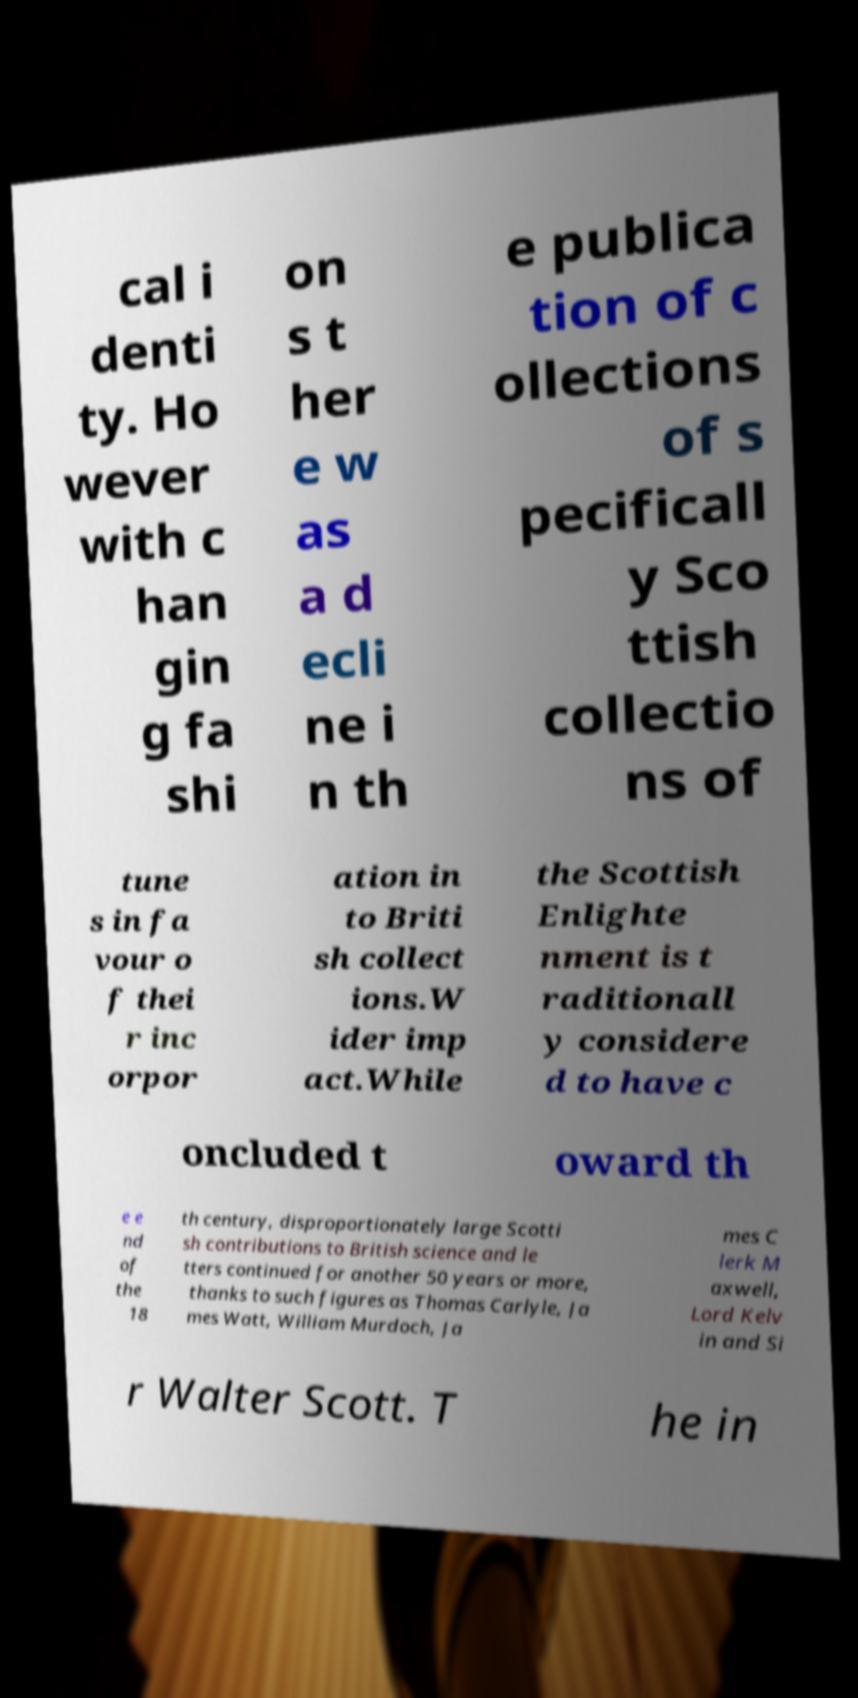I need the written content from this picture converted into text. Can you do that? cal i denti ty. Ho wever with c han gin g fa shi on s t her e w as a d ecli ne i n th e publica tion of c ollections of s pecificall y Sco ttish collectio ns of tune s in fa vour o f thei r inc orpor ation in to Briti sh collect ions.W ider imp act.While the Scottish Enlighte nment is t raditionall y considere d to have c oncluded t oward th e e nd of the 18 th century, disproportionately large Scotti sh contributions to British science and le tters continued for another 50 years or more, thanks to such figures as Thomas Carlyle, Ja mes Watt, William Murdoch, Ja mes C lerk M axwell, Lord Kelv in and Si r Walter Scott. T he in 